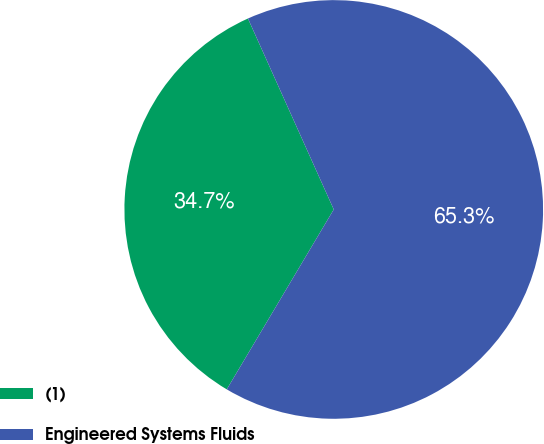<chart> <loc_0><loc_0><loc_500><loc_500><pie_chart><fcel>(1)<fcel>Engineered Systems Fluids<nl><fcel>34.74%<fcel>65.26%<nl></chart> 